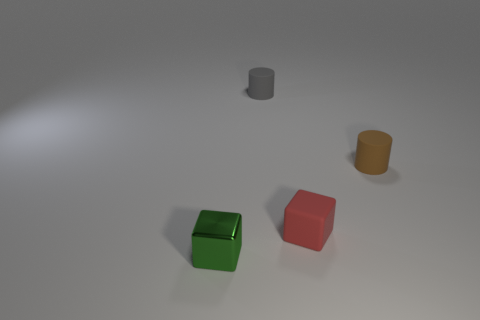Add 1 small red matte blocks. How many objects exist? 5 Subtract all red rubber cubes. Subtract all rubber cubes. How many objects are left? 2 Add 3 rubber things. How many rubber things are left? 6 Add 3 large blue rubber things. How many large blue rubber things exist? 3 Subtract 0 cyan balls. How many objects are left? 4 